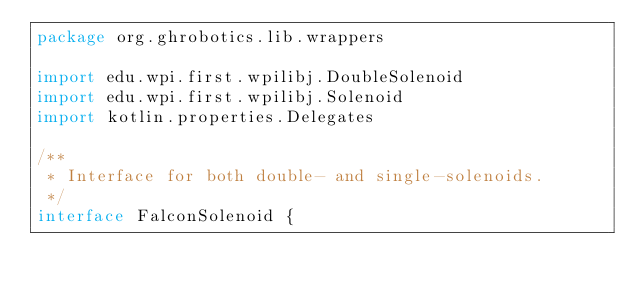<code> <loc_0><loc_0><loc_500><loc_500><_Kotlin_>package org.ghrobotics.lib.wrappers

import edu.wpi.first.wpilibj.DoubleSolenoid
import edu.wpi.first.wpilibj.Solenoid
import kotlin.properties.Delegates

/**
 * Interface for both double- and single-solenoids.
 */
interface FalconSolenoid {</code> 